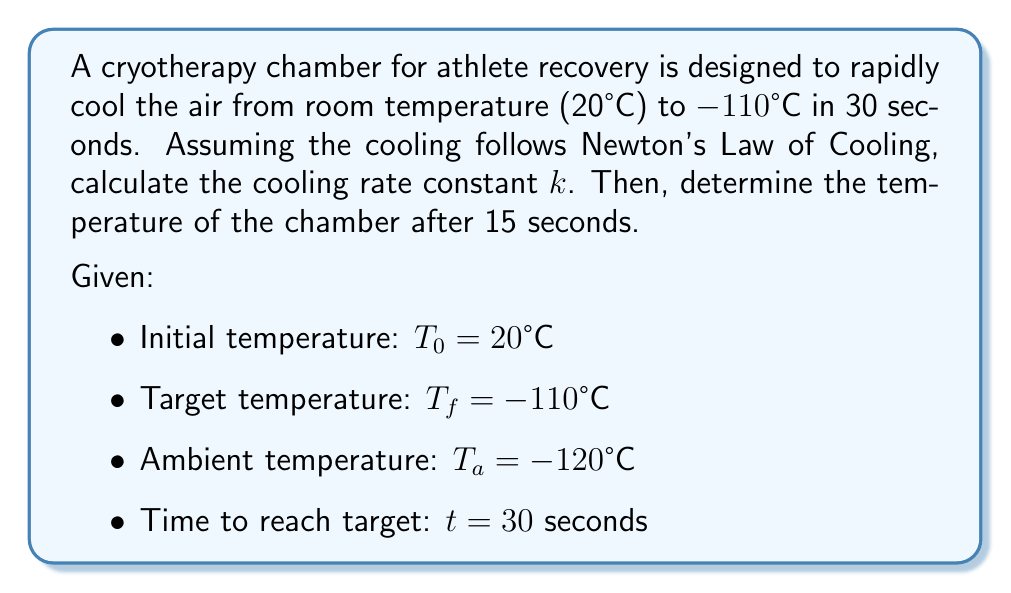Provide a solution to this math problem. 1) Newton's Law of Cooling is given by:
   $$T(t) = T_a + (T_0 - T_a)e^{-kt}$$

2) At t = 30 seconds, T(t) = $T_f = -110°C$. Substituting into the equation:
   $$-110 = -120 + (20 + 120)e^{-k(30)}$$

3) Simplify:
   $$10 = 140e^{-30k}$$

4) Divide both sides by 140:
   $$\frac{1}{14} = e^{-30k}$$

5) Take the natural log of both sides:
   $$\ln(\frac{1}{14}) = -30k$$

6) Solve for k:
   $$k = -\frac{1}{30}\ln(\frac{1}{14}) \approx 0.0885$$

7) Now that we have k, we can find the temperature at t = 15 seconds:
   $$T(15) = -120 + (20 + 120)e^{-0.0885(15)}$$

8) Simplify:
   $$T(15) = -120 + 140e^{-1.3275} \approx -45.8°C$$
Answer: $k \approx 0.0885$ $s^{-1}$, $T(15) \approx -45.8°C$ 